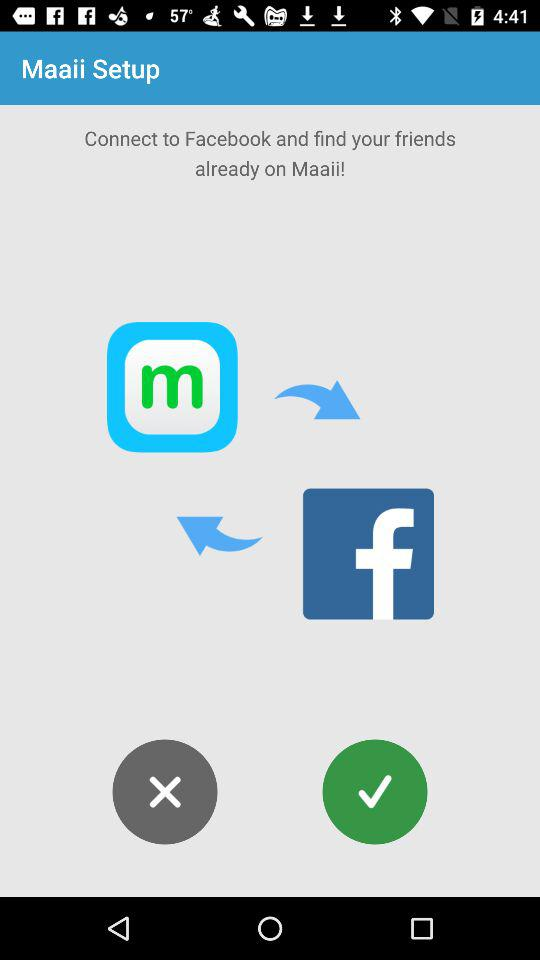What application is given for Maaii to find friends? The given application is Facebook for Maaii to find friends. 